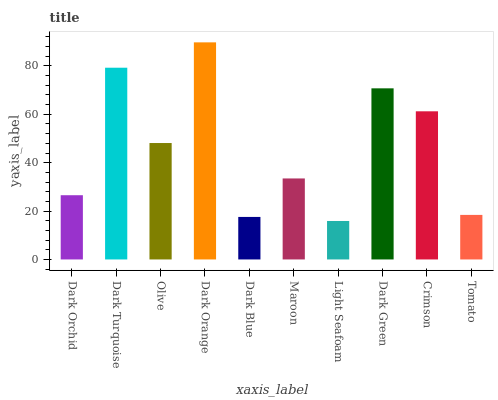Is Light Seafoam the minimum?
Answer yes or no. Yes. Is Dark Orange the maximum?
Answer yes or no. Yes. Is Dark Turquoise the minimum?
Answer yes or no. No. Is Dark Turquoise the maximum?
Answer yes or no. No. Is Dark Turquoise greater than Dark Orchid?
Answer yes or no. Yes. Is Dark Orchid less than Dark Turquoise?
Answer yes or no. Yes. Is Dark Orchid greater than Dark Turquoise?
Answer yes or no. No. Is Dark Turquoise less than Dark Orchid?
Answer yes or no. No. Is Olive the high median?
Answer yes or no. Yes. Is Maroon the low median?
Answer yes or no. Yes. Is Dark Turquoise the high median?
Answer yes or no. No. Is Crimson the low median?
Answer yes or no. No. 